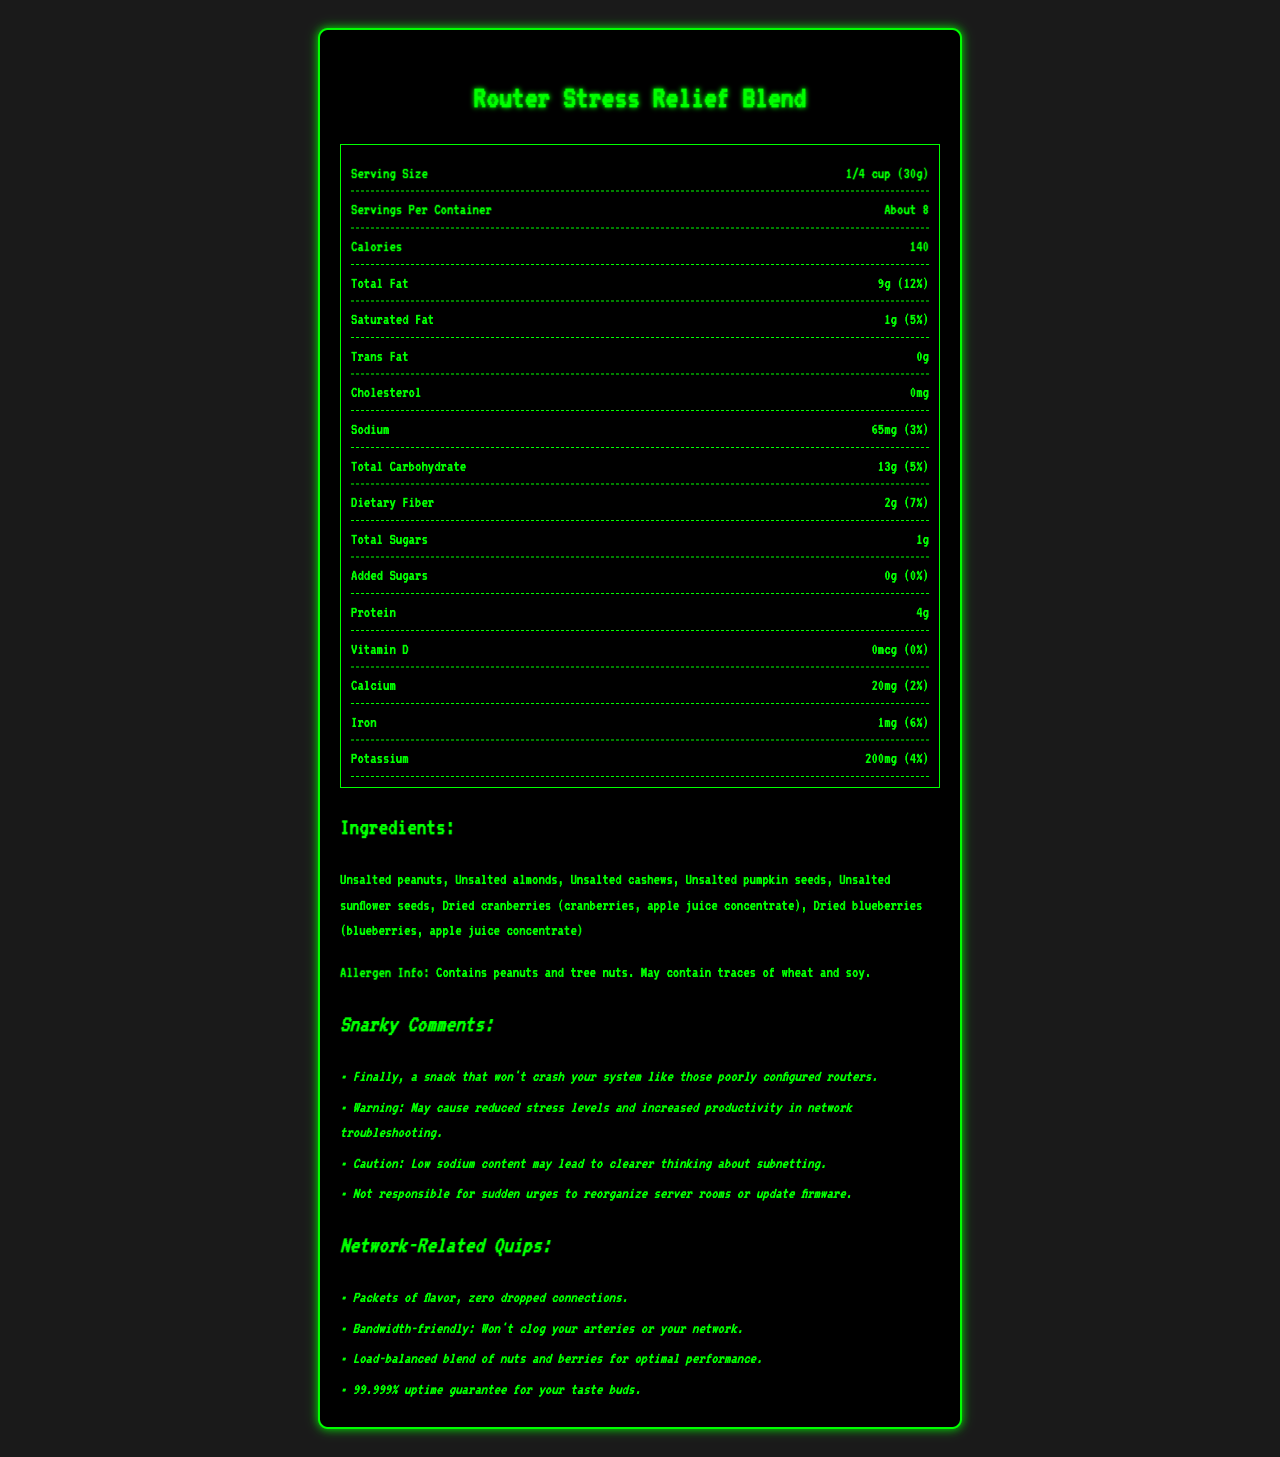what is the serving size? The serving size is explicitly stated as "1/4 cup (30g)" in the document.
Answer: 1/4 cup (30g) how many servings are there per container? The servings per container are listed as "About 8" in the document.
Answer: About 8 how many calories are in one serving of Router Stress Relief Blend? The calorie content per serving is shown as 140.
Answer: 140 what is the total fat content in this snack mix? The total fat content is listed as 9g, accounting for 12% of the daily value.
Answer: 9g (12%) what ingredients are used in Router Stress Relief Blend? The ingredient list includes all these items as provided in the Ingredients section.
Answer: Unsalted peanuts, Unsalted almonds, Unsalted cashews, Unsalted pumpkin seeds, Unsalted sunflower seeds, Dried cranberries (cranberries, apple juice concentrate), Dried blueberries (blueberries, apple juice concentrate) how much sodium does one serving contain? The sodium content per serving is listed as 65mg, which is 3% of the daily value.
Answer: 65mg (3%) what is the amount of dietary fiber per serving? The dietary fiber content per serving is 2g, contributing to 7% of the daily value.
Answer: 2g (7%) how much sugar does this product have? The document lists 1g of total sugars and 0g added sugars, which contribute to 0% of the daily value.
Answer: Total Sugars: 1g, Added Sugars: 0g (0%) what vitamins and minerals are included and in what amounts? The document lists the amounts for Vitamin D (0mcg, 0%), Calcium (20mg, 2%), Iron (1mg, 6%), and Potassium (200mg, 4%).
Answer: Vitamin D: 0mcg (0%), Calcium: 20mg (2%), Iron: 1mg (6%), Potassium: 200mg (4%) what allergens should be noted for this product? The allergen information is specified in the Allergen Info section.
Answer: Contains peanuts and tree nuts. May contain traces of wheat and soy. what snarky comment implies an improvement in thinking about subnetting? The specific snarky comment referencing improved subnetting cognition is noted in the document.
Answer: Caution: Low sodium content may lead to clearer thinking about subnetting. which network-related quip highlights the product's effect on health? The quip associates the product with being beneficial both for network performance and arterial health.
Answer: Bandwidth-friendly: Won't clog your arteries or your network. what is the total carbohydrate content per serving? The total carbohydrate content per serving is listed as 13g, which is 5% of the daily value.
Answer: 13g (5%) what is the protein content of this snack mix? The protein content per serving is listed as 4g.
Answer: 4g what's the cautionary note about the snack mix's effect on network troubleshooting? A. May lead to more dropped packets B. May make subnetting harder C. May cause reduced stress levels and increased productivity D. May lead to network congestion The document contains the snarky comment: "Warning: May cause reduced stress levels and increased productivity in network troubleshooting."
Answer: C what is the guarantee given for the taste experience of Router Stress Relief Blend? A. 99.9% B. 99.999% C. 100% D. 98.9% The document includes a quip that states a "99.999% uptime guarantee for your taste buds."
Answer: B does this product contain any cholesterol? As stated in the document, the cholesterol content is 0mg.
Answer: No summarize the main idea of the document. This document provides comprehensive information about the nutritional content, ingredients, and humor related to the Router Stress Relief Blend, emphasizing its health benefits and fun network engineer-related remarks.
Answer: The document presents the Nutrition Facts Label for Router Stress Relief Blend, a low-sodium snack mix. It details the nutritional contents, ingredients, allergen information, and provides snarky comments and network-related quips for added humor. what is the serving size for Router Stress Relief Blend in ounces? The document provides the serving size in cups (1/4 cup) and grams (30g), but does not convert this measurement to ounces. Therefore, the information is not directly available.
Answer: Cannot be determined 